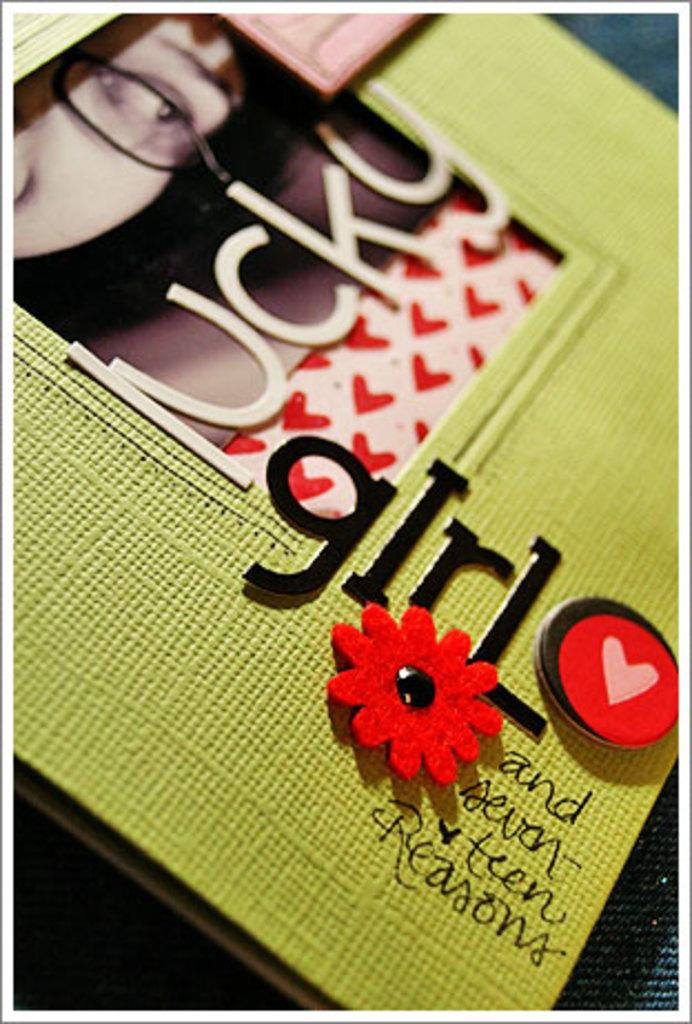What is the main object in the image? There is a greeting card in the image. What can be found on the greeting card? Text is written on the greeting card, and there is a photograph in the middle of it. Where is the greeting card placed? The greeting card is on a platform. How much honey is on the greeting card in the image? There is no honey present on the greeting card in the image. Can you see any ducks in the photograph on the greeting card? There is no information about the content of the photograph on the greeting card, so it cannot be determined if ducks are present. 